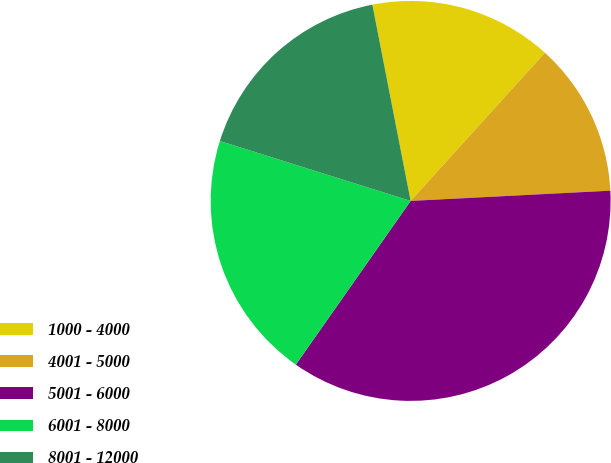Convert chart. <chart><loc_0><loc_0><loc_500><loc_500><pie_chart><fcel>1000 - 4000<fcel>4001 - 5000<fcel>5001 - 6000<fcel>6001 - 8000<fcel>8001 - 12000<nl><fcel>14.78%<fcel>12.47%<fcel>35.55%<fcel>20.11%<fcel>17.09%<nl></chart> 